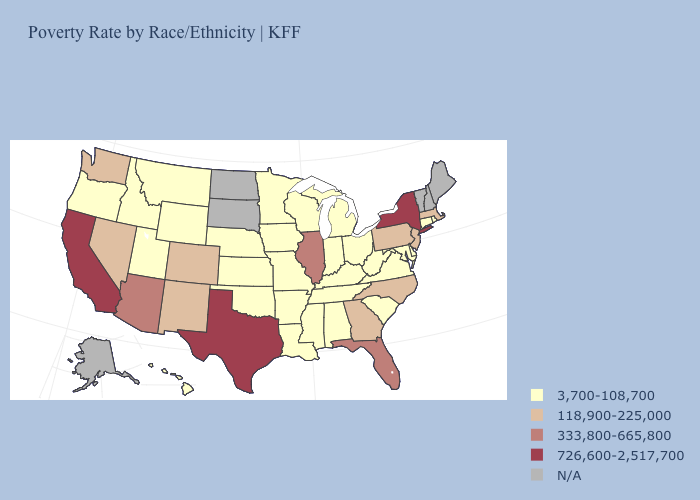Among the states that border Nevada , does Utah have the lowest value?
Give a very brief answer. Yes. How many symbols are there in the legend?
Give a very brief answer. 5. Name the states that have a value in the range 726,600-2,517,700?
Answer briefly. California, New York, Texas. Name the states that have a value in the range 3,700-108,700?
Answer briefly. Alabama, Arkansas, Connecticut, Delaware, Hawaii, Idaho, Indiana, Iowa, Kansas, Kentucky, Louisiana, Maryland, Michigan, Minnesota, Mississippi, Missouri, Montana, Nebraska, Ohio, Oklahoma, Oregon, Rhode Island, South Carolina, Tennessee, Utah, Virginia, West Virginia, Wisconsin, Wyoming. Name the states that have a value in the range N/A?
Short answer required. Alaska, Maine, New Hampshire, North Dakota, South Dakota, Vermont. What is the value of Alabama?
Give a very brief answer. 3,700-108,700. What is the lowest value in the Northeast?
Concise answer only. 3,700-108,700. What is the value of Alaska?
Quick response, please. N/A. Which states have the lowest value in the Northeast?
Give a very brief answer. Connecticut, Rhode Island. Name the states that have a value in the range N/A?
Concise answer only. Alaska, Maine, New Hampshire, North Dakota, South Dakota, Vermont. What is the value of California?
Quick response, please. 726,600-2,517,700. Which states have the lowest value in the USA?
Quick response, please. Alabama, Arkansas, Connecticut, Delaware, Hawaii, Idaho, Indiana, Iowa, Kansas, Kentucky, Louisiana, Maryland, Michigan, Minnesota, Mississippi, Missouri, Montana, Nebraska, Ohio, Oklahoma, Oregon, Rhode Island, South Carolina, Tennessee, Utah, Virginia, West Virginia, Wisconsin, Wyoming. Name the states that have a value in the range 726,600-2,517,700?
Give a very brief answer. California, New York, Texas. Which states have the lowest value in the South?
Be succinct. Alabama, Arkansas, Delaware, Kentucky, Louisiana, Maryland, Mississippi, Oklahoma, South Carolina, Tennessee, Virginia, West Virginia. Among the states that border Arizona , which have the lowest value?
Quick response, please. Utah. 